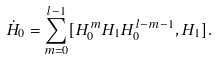Convert formula to latex. <formula><loc_0><loc_0><loc_500><loc_500>\dot { H } _ { 0 } = \sum _ { m = 0 } ^ { l - 1 } [ H _ { 0 } ^ { m } H _ { 1 } H _ { 0 } ^ { l - m - 1 } , H _ { 1 } ] .</formula> 